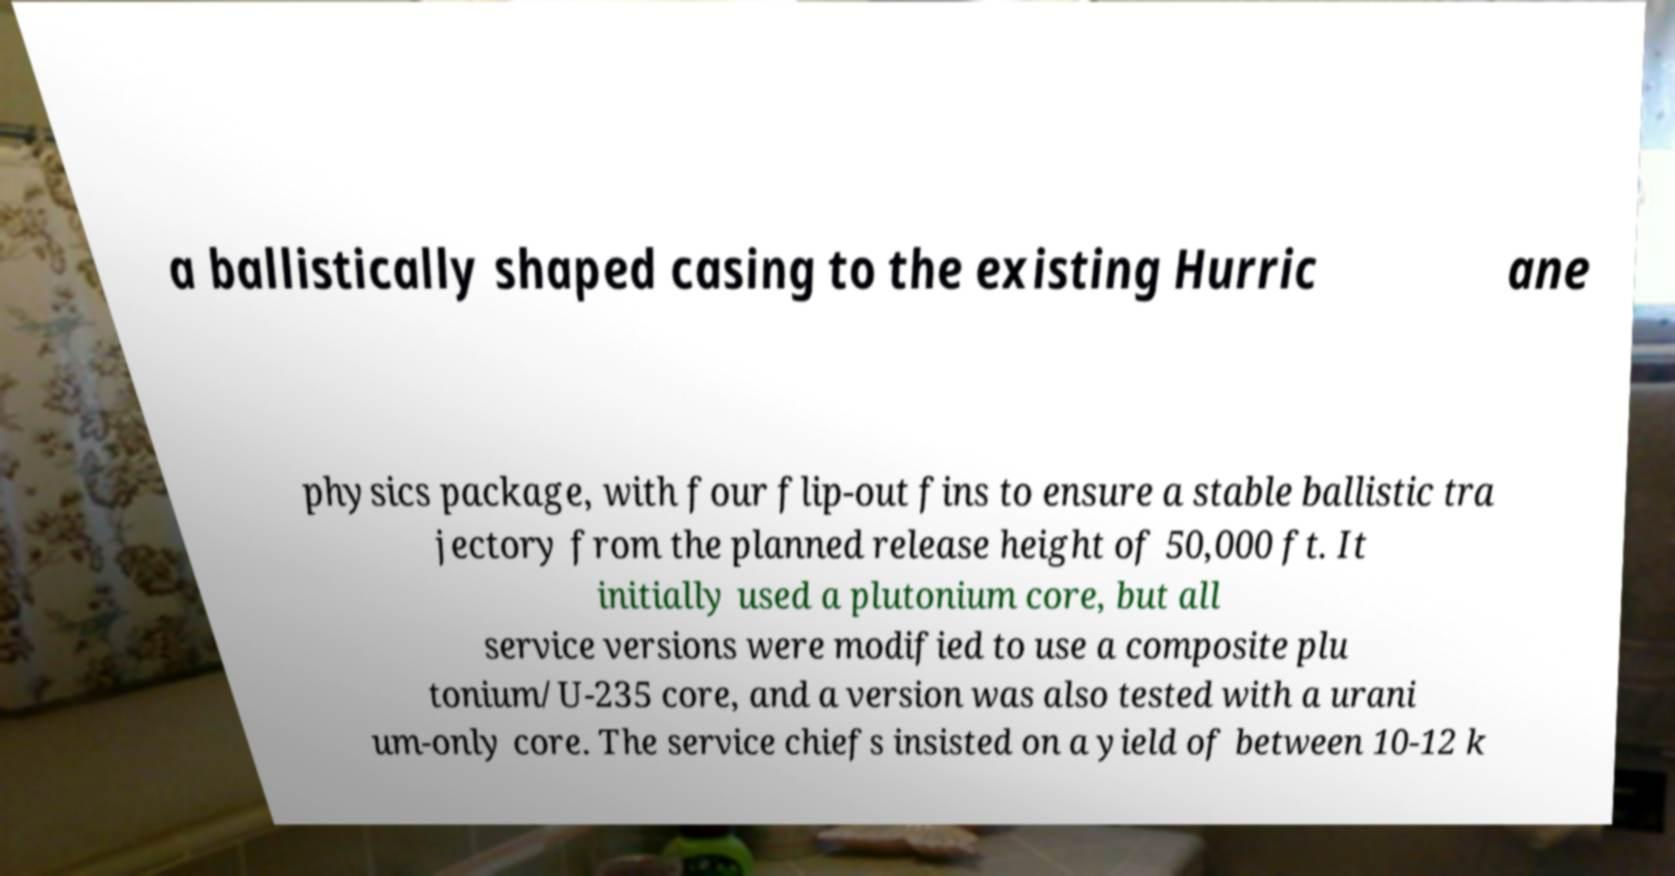What messages or text are displayed in this image? I need them in a readable, typed format. a ballistically shaped casing to the existing Hurric ane physics package, with four flip-out fins to ensure a stable ballistic tra jectory from the planned release height of 50,000 ft. It initially used a plutonium core, but all service versions were modified to use a composite plu tonium/U-235 core, and a version was also tested with a urani um-only core. The service chiefs insisted on a yield of between 10-12 k 